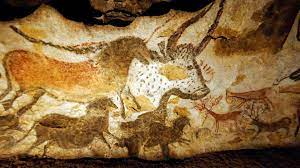Can you point out and describe some specific animals that are depicted in the Lascaux Cave paintings? Certainly! One prominent figure in the Lascaux Cave paintings is a large bull, known as the Great Bull, which dominates one of the panels. There are also several horses, depicted with elegant, curving lines and multiple shades of color, suggesting movement and depth. Deer are another frequent subject, shown with fine, detailed antlers. These images not only exhibit the artistry and observational skills of the Paleolithic artists but also their deep connection to the animals they relied on and revered. How have these paintings survived so well through the millennia? The remarkable preservation of the Lascaux Cave paintings can be attributed to several factors. Primarily, the constant temperature and humidity inside the cave played crucial roles. Additionally, these caves were sealed and protected from external elements for thousands of years until their rediscovery, which has helped the artworks avoid exposure to weathering and human interference. Modern preservation efforts also include restricting access to the caves to prevent damage from carbon dioxide and moisture from visitors. 